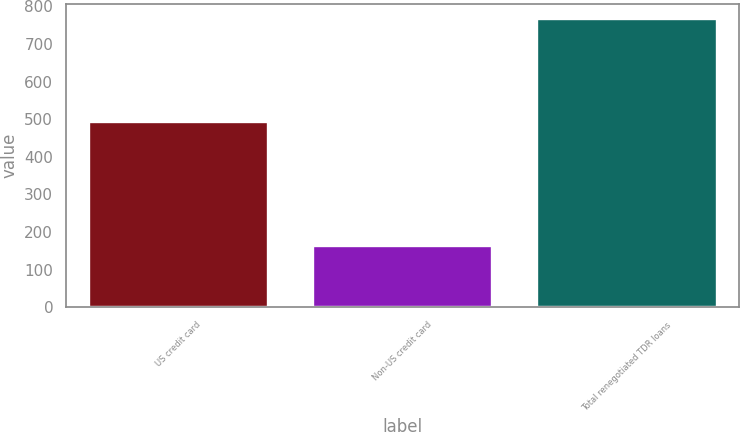<chart> <loc_0><loc_0><loc_500><loc_500><bar_chart><fcel>US credit card<fcel>Non-US credit card<fcel>Total renegotiated TDR loans<nl><fcel>492<fcel>163<fcel>767<nl></chart> 